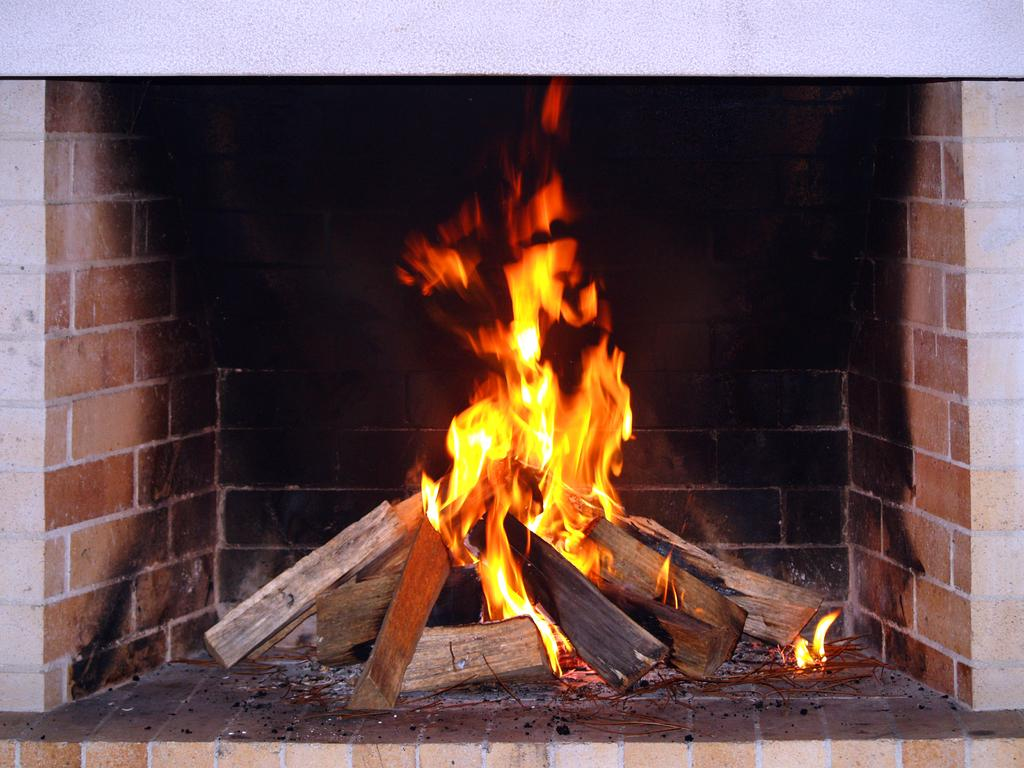What type of structure is present in the image? There is a fireplace in the image. What color is the wall behind the fireplace? There is a white wall in the image. What type of notebook is being used by the person sitting on the floor near the fireplace? There is no person or notebook present in the image; it only features a fireplace and a white wall. 